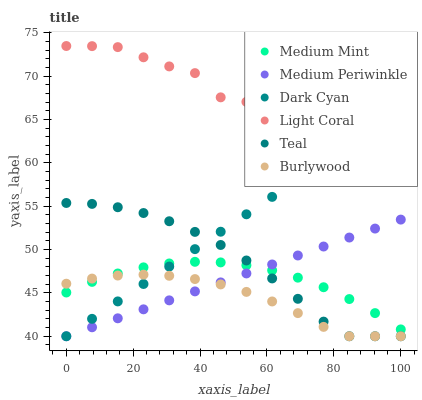Does Burlywood have the minimum area under the curve?
Answer yes or no. Yes. Does Light Coral have the maximum area under the curve?
Answer yes or no. Yes. Does Medium Periwinkle have the minimum area under the curve?
Answer yes or no. No. Does Medium Periwinkle have the maximum area under the curve?
Answer yes or no. No. Is Dark Cyan the smoothest?
Answer yes or no. Yes. Is Light Coral the roughest?
Answer yes or no. Yes. Is Burlywood the smoothest?
Answer yes or no. No. Is Burlywood the roughest?
Answer yes or no. No. Does Burlywood have the lowest value?
Answer yes or no. Yes. Does Light Coral have the lowest value?
Answer yes or no. No. Does Light Coral have the highest value?
Answer yes or no. Yes. Does Medium Periwinkle have the highest value?
Answer yes or no. No. Is Medium Mint less than Light Coral?
Answer yes or no. Yes. Is Light Coral greater than Burlywood?
Answer yes or no. Yes. Does Teal intersect Medium Mint?
Answer yes or no. Yes. Is Teal less than Medium Mint?
Answer yes or no. No. Is Teal greater than Medium Mint?
Answer yes or no. No. Does Medium Mint intersect Light Coral?
Answer yes or no. No. 